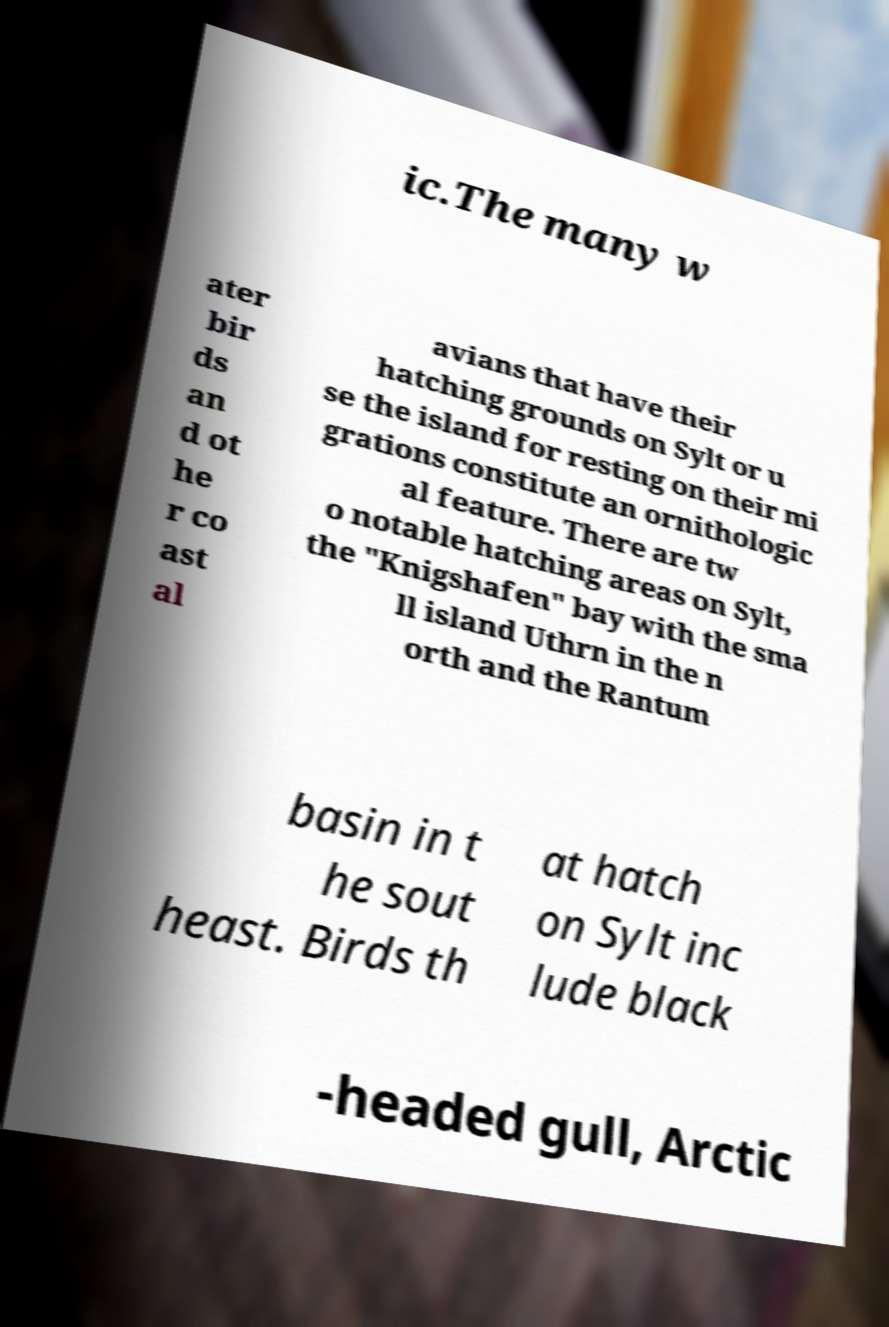For documentation purposes, I need the text within this image transcribed. Could you provide that? ic.The many w ater bir ds an d ot he r co ast al avians that have their hatching grounds on Sylt or u se the island for resting on their mi grations constitute an ornithologic al feature. There are tw o notable hatching areas on Sylt, the "Knigshafen" bay with the sma ll island Uthrn in the n orth and the Rantum basin in t he sout heast. Birds th at hatch on Sylt inc lude black -headed gull, Arctic 